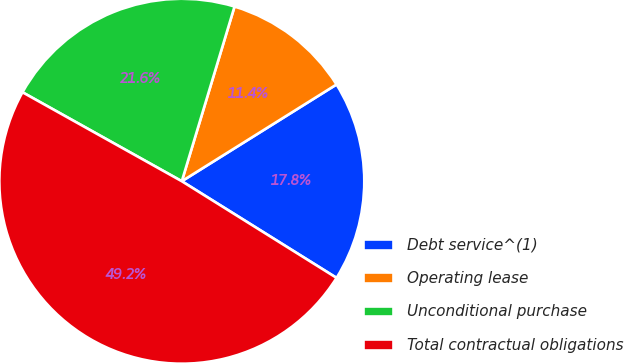Convert chart to OTSL. <chart><loc_0><loc_0><loc_500><loc_500><pie_chart><fcel>Debt service^(1)<fcel>Operating lease<fcel>Unconditional purchase<fcel>Total contractual obligations<nl><fcel>17.78%<fcel>11.44%<fcel>21.56%<fcel>49.22%<nl></chart> 